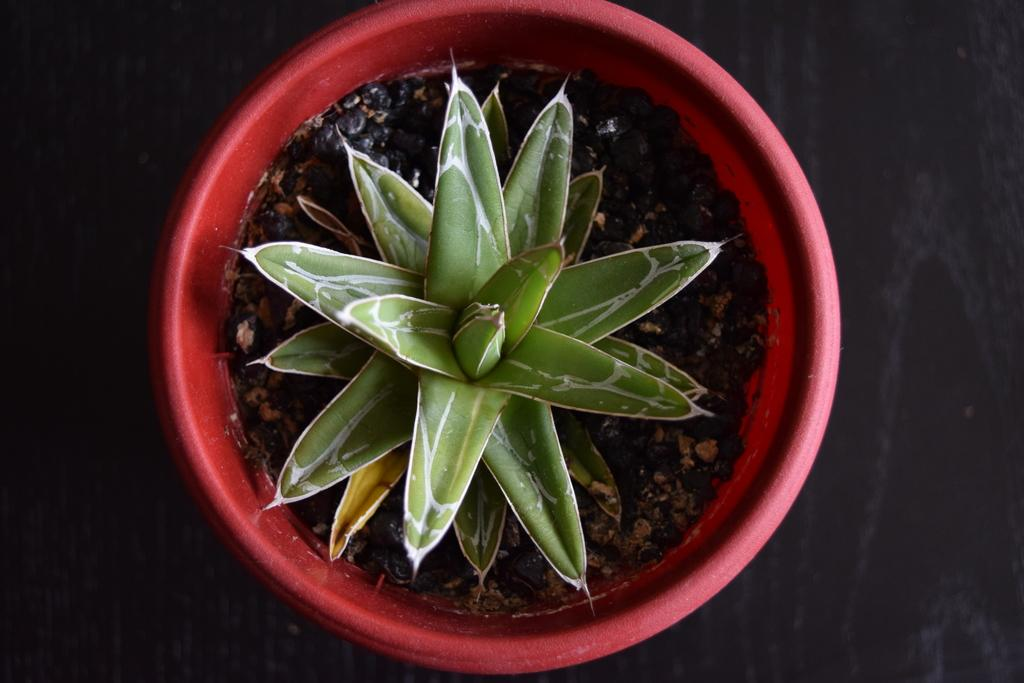What is present in the image? There is a plant in the image. What is the color of the pot in which the plant is placed? The plant is in a red-colored pot. What color can be seen in the background of the image? There is black color visible in the background of the image. What route does the plant take to reach the north in the image? The plant does not take any route to reach the north in the image, as it is a static object and not capable of movement. 